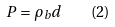Convert formula to latex. <formula><loc_0><loc_0><loc_500><loc_500>P = \rho _ { b } d \quad ( 2 )</formula> 